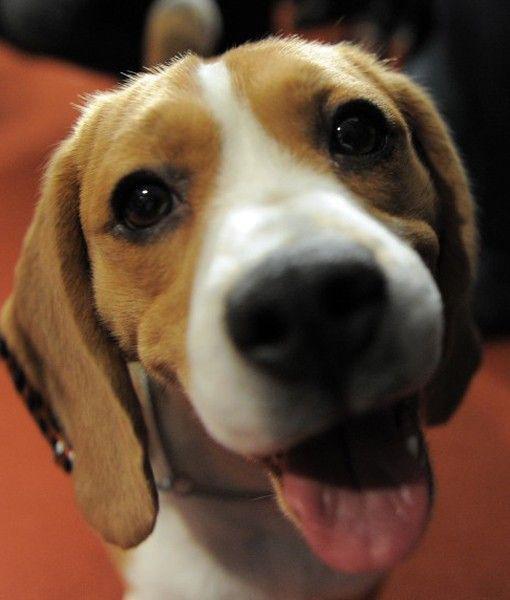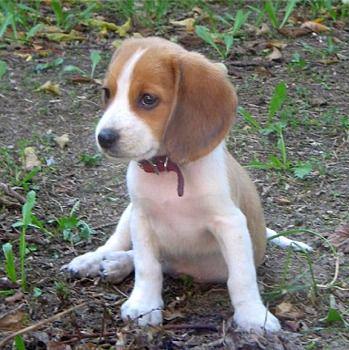The first image is the image on the left, the second image is the image on the right. For the images shown, is this caption "beagles are sitting or standing in green grass" true? Answer yes or no. No. The first image is the image on the left, the second image is the image on the right. Assess this claim about the two images: "An image shows a dog looking up at the camera with a semi-circular shape under its nose.". Correct or not? Answer yes or no. Yes. 